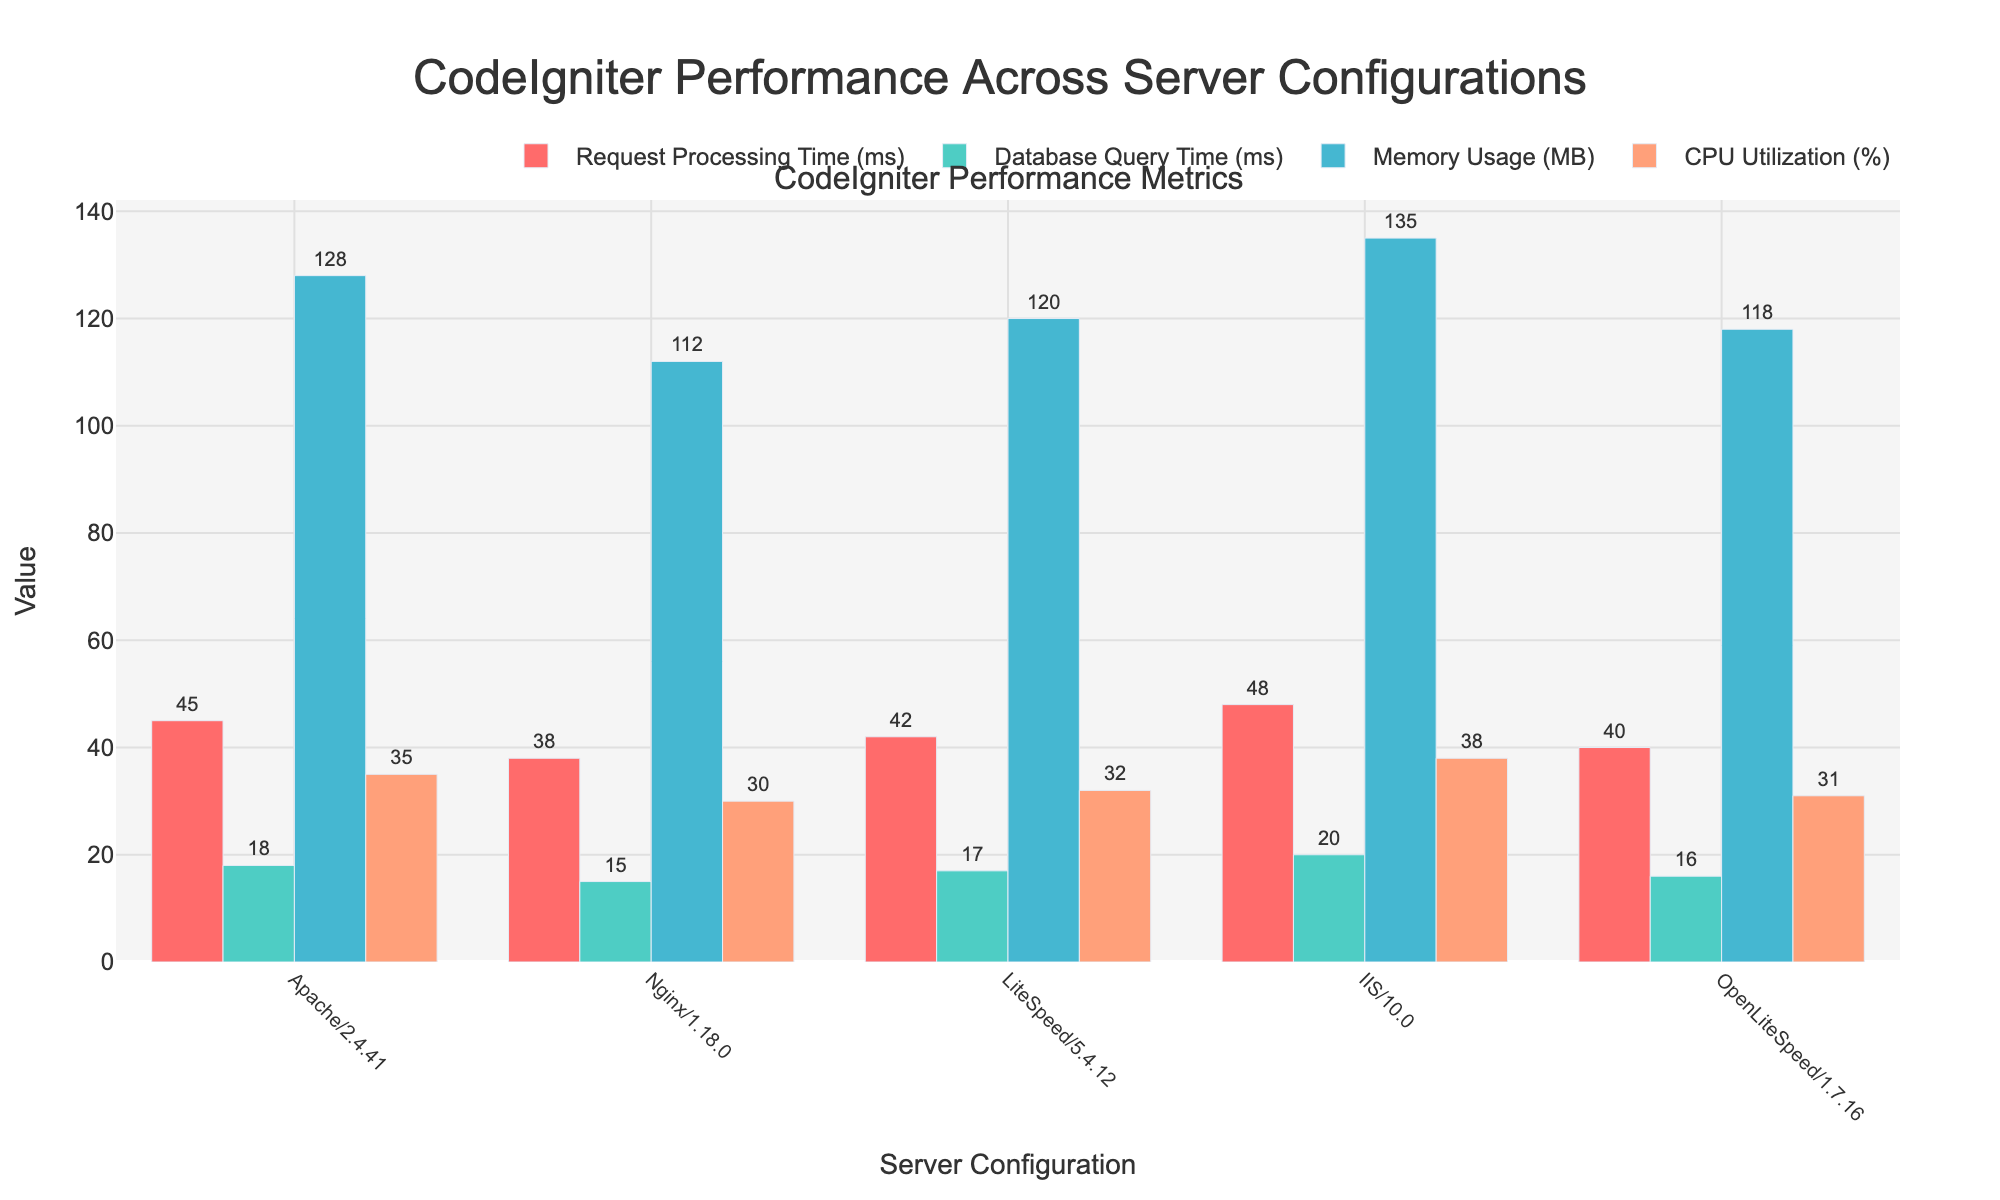What is the title of the figure? The title is usually located at the top of the figure, and for this particular plot, it would ascertain the focus of the data representation. The title "CodeIgniter Performance Across Server Configurations" clearly indicates it is about comparing various performance metrics for the CodeIgniter framework against different server configurations.
Answer: CodeIgniter Performance Across Server Configurations How many server configurations are compared in the figure? By looking at the x-axis, we can count the number of server configurations listed. Each server configuration is represented once on this axis. There are five server configurations: Apache/2.4.41, Nginx/1.18.0, LiteSpeed/5.4.12, IIS/10.0, and OpenLiteSpeed/1.7.16.
Answer: 5 Which server configuration shows the highest memory usage? To find the answer, look at the bar representing the memory usage for each server configuration. The one with the tallest bar in the 'Memory Usage (MB)' metric indicates the highest usage. IIS/10.0 has the highest memory usage.
Answer: IIS/10.0 What is the difference in request processing time between Apache/2.4.41 and Nginx/1.18.0? To calculate the difference, subtract the value of request processing time for Nginx/1.18.0 from that of Apache/2.4.41. Apache/2.4.41 has 45 ms, and Nginx/1.18.0 has 38 ms. 45 - 38 = 7 ms.
Answer: 7 ms Which performance metric has the smallest range across server configurations? To find the smallest range, calculate the range (difference between the highest and lowest values) for each performance metric across all server configurations. Request Processing Time ranges from 38 ms to 48 ms (range = 10 ms), Database Query Time ranges from 15 ms to 20 ms (range = 5 ms), Memory Usage ranges from 112 MB to 135 MB (range = 23 MB), and CPU Utilization ranges from 30% to 38% (range = 8%). The smallest range is in Database Query Time.
Answer: Database Query Time Which server configuration has the best overall performance in terms of request processing time and memory usage combined? To determine the best performance, consider lower values for request processing time and memory usage as better performance indicators. Nginx/1.18.0 has the lowest request processing time (38 ms) and the lowest memory usage (112 MB) among the configurations, indicating the best overall performance in these metrics.
Answer: Nginx/1.18.0 Which server configuration exhibits the highest CPU utilization? By looking at the height of the bars representing CPU Utilization for each server configuration, the one with the tallest bar will indicate the highest usage. IIS/10.0 shows the highest CPU Utilization at 38%.
Answer: IIS/10.0 If you were to rank the server configurations based on database query time, which configuration would come second? To rank by database query time, arrange the configurations in ascending order. The times are: Nginx/1.18.0 (15 ms), OpenLiteSpeed/1.7.16 (16 ms), LiteSpeed/5.4.12 (17 ms), Apache/2.4.41 (18 ms), IIS/10.0 (20 ms). The second configuration is OpenLiteSpeed/1.7.16.
Answer: OpenLiteSpeed/1.7.16 Which metrics show Apache/2.4.41 performing better than LiteSpeed/5.4.12? To determine this, compare the corresponding bars for Apache/2.4.41 and LiteSpeed/5.4.12 for each metric. Apache/2.4.41 performs better than LiteSpeed/5.4.12 in Database Query Time (18 ms vs. 17 ms) and CPU Utilization (35% vs. 32%).
Answer: Database Query Time and CPU Utilization 